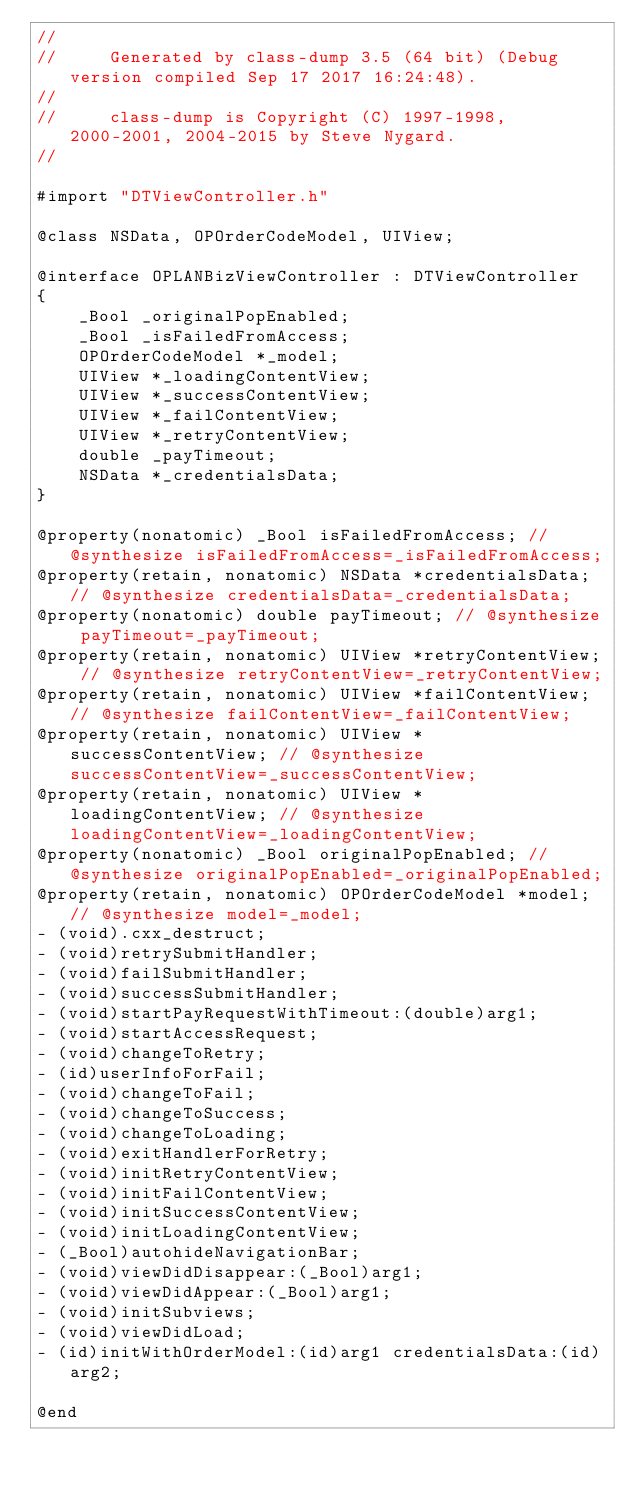Convert code to text. <code><loc_0><loc_0><loc_500><loc_500><_C_>//
//     Generated by class-dump 3.5 (64 bit) (Debug version compiled Sep 17 2017 16:24:48).
//
//     class-dump is Copyright (C) 1997-1998, 2000-2001, 2004-2015 by Steve Nygard.
//

#import "DTViewController.h"

@class NSData, OPOrderCodeModel, UIView;

@interface OPLANBizViewController : DTViewController
{
    _Bool _originalPopEnabled;
    _Bool _isFailedFromAccess;
    OPOrderCodeModel *_model;
    UIView *_loadingContentView;
    UIView *_successContentView;
    UIView *_failContentView;
    UIView *_retryContentView;
    double _payTimeout;
    NSData *_credentialsData;
}

@property(nonatomic) _Bool isFailedFromAccess; // @synthesize isFailedFromAccess=_isFailedFromAccess;
@property(retain, nonatomic) NSData *credentialsData; // @synthesize credentialsData=_credentialsData;
@property(nonatomic) double payTimeout; // @synthesize payTimeout=_payTimeout;
@property(retain, nonatomic) UIView *retryContentView; // @synthesize retryContentView=_retryContentView;
@property(retain, nonatomic) UIView *failContentView; // @synthesize failContentView=_failContentView;
@property(retain, nonatomic) UIView *successContentView; // @synthesize successContentView=_successContentView;
@property(retain, nonatomic) UIView *loadingContentView; // @synthesize loadingContentView=_loadingContentView;
@property(nonatomic) _Bool originalPopEnabled; // @synthesize originalPopEnabled=_originalPopEnabled;
@property(retain, nonatomic) OPOrderCodeModel *model; // @synthesize model=_model;
- (void).cxx_destruct;
- (void)retrySubmitHandler;
- (void)failSubmitHandler;
- (void)successSubmitHandler;
- (void)startPayRequestWithTimeout:(double)arg1;
- (void)startAccessRequest;
- (void)changeToRetry;
- (id)userInfoForFail;
- (void)changeToFail;
- (void)changeToSuccess;
- (void)changeToLoading;
- (void)exitHandlerForRetry;
- (void)initRetryContentView;
- (void)initFailContentView;
- (void)initSuccessContentView;
- (void)initLoadingContentView;
- (_Bool)autohideNavigationBar;
- (void)viewDidDisappear:(_Bool)arg1;
- (void)viewDidAppear:(_Bool)arg1;
- (void)initSubviews;
- (void)viewDidLoad;
- (id)initWithOrderModel:(id)arg1 credentialsData:(id)arg2;

@end

</code> 